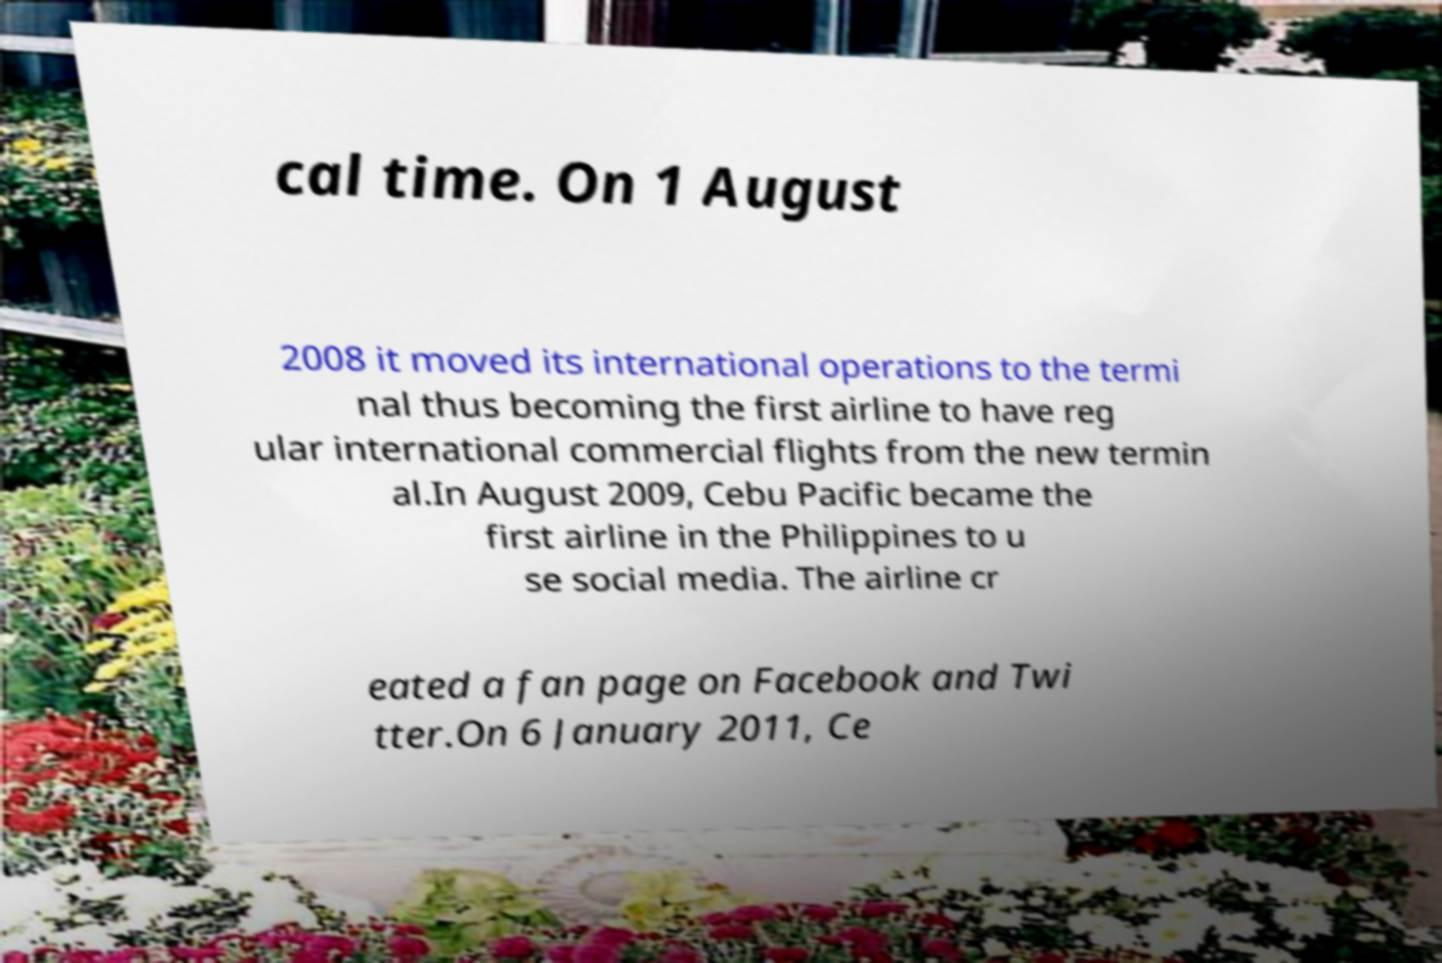Can you read and provide the text displayed in the image?This photo seems to have some interesting text. Can you extract and type it out for me? cal time. On 1 August 2008 it moved its international operations to the termi nal thus becoming the first airline to have reg ular international commercial flights from the new termin al.In August 2009, Cebu Pacific became the first airline in the Philippines to u se social media. The airline cr eated a fan page on Facebook and Twi tter.On 6 January 2011, Ce 